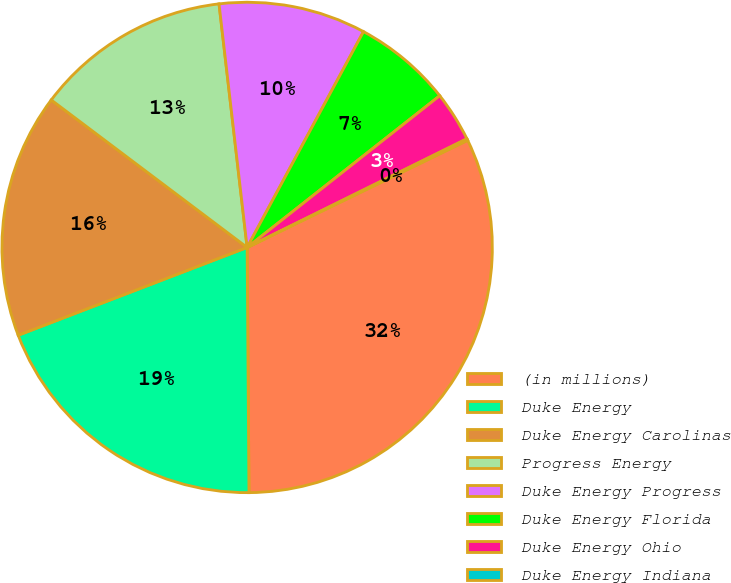Convert chart to OTSL. <chart><loc_0><loc_0><loc_500><loc_500><pie_chart><fcel>(in millions)<fcel>Duke Energy<fcel>Duke Energy Carolinas<fcel>Progress Energy<fcel>Duke Energy Progress<fcel>Duke Energy Florida<fcel>Duke Energy Ohio<fcel>Duke Energy Indiana<nl><fcel>32.08%<fcel>19.29%<fcel>16.1%<fcel>12.9%<fcel>9.7%<fcel>6.51%<fcel>3.31%<fcel>0.11%<nl></chart> 